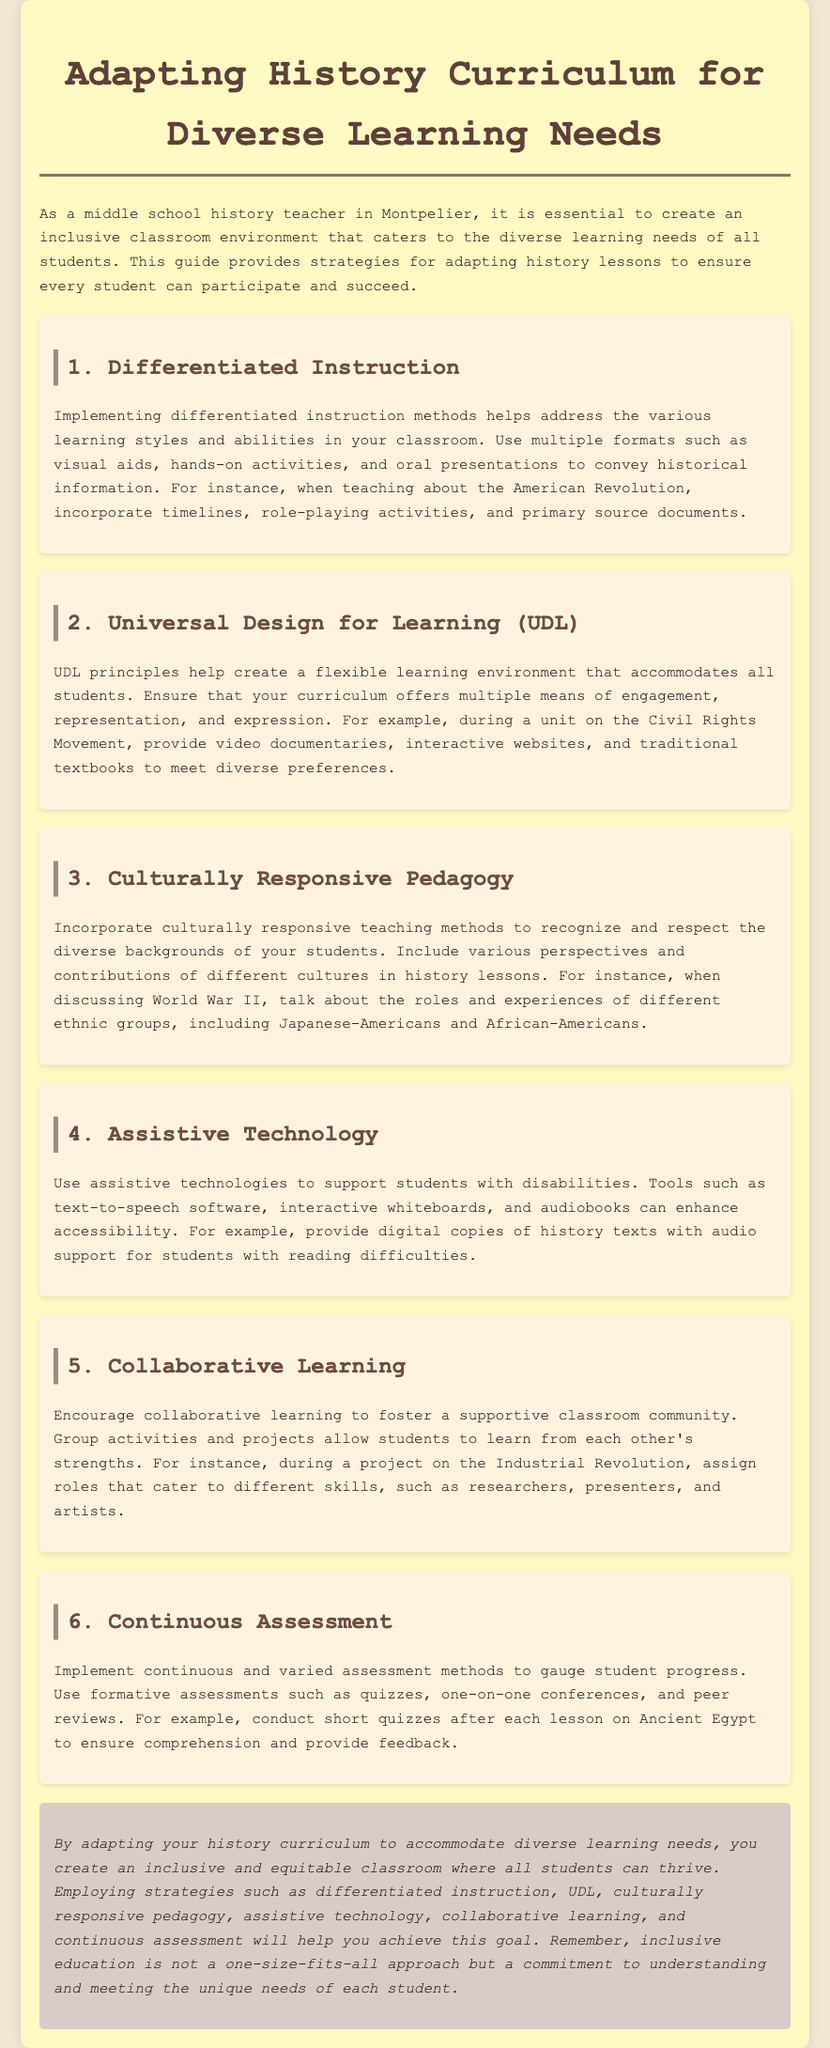What is the first strategy mentioned in the guide? The first strategy mentioned is "Differentiated Instruction," which is outlined in section 1 of the document.
Answer: Differentiated Instruction What principle does UDL stand for? UDL is an acronym found in section 2, meaning "Universal Design for Learning."
Answer: Universal Design for Learning Which ethnic groups are highlighted in the discussion of World War II? The guide includes specific ethnic groups such as Japanese-Americans and African-Americans as mentioned in section 3.
Answer: Japanese-Americans and African-Americans What type of assessment is recommended to gauge student progress? In section 6, the document suggests using continuous assessment methods, indicating they may include quizzes and peer reviews.
Answer: Continuous assessment How many sections are dedicated to strategies for adapting the history curriculum? The guide includes six distinct sections, each detailing a different strategy for adaptation in the curriculum.
Answer: Six What is the main goal of adapting the history curriculum according to the conclusion? The main goal is creating an inclusive classroom where all students can thrive. This is emphasized in the conclusion of the document.
Answer: Inclusive classroom What technology is suggested to support students with disabilities? In section 4, various assistive technologies, like text-to-speech software and audiobooks, are mentioned for supporting students with disabilities.
Answer: Assistive technologies During which historical unit is the use of video documentaries recommended? Video documentaries are recommended during a unit on the Civil Rights Movement, as mentioned in section 2.
Answer: Civil Rights Movement What type of learning is encouraged to foster a supportive community? Section 5 discusses the encouragement of collaborative learning to foster a supportive classroom environment.
Answer: Collaborative learning 